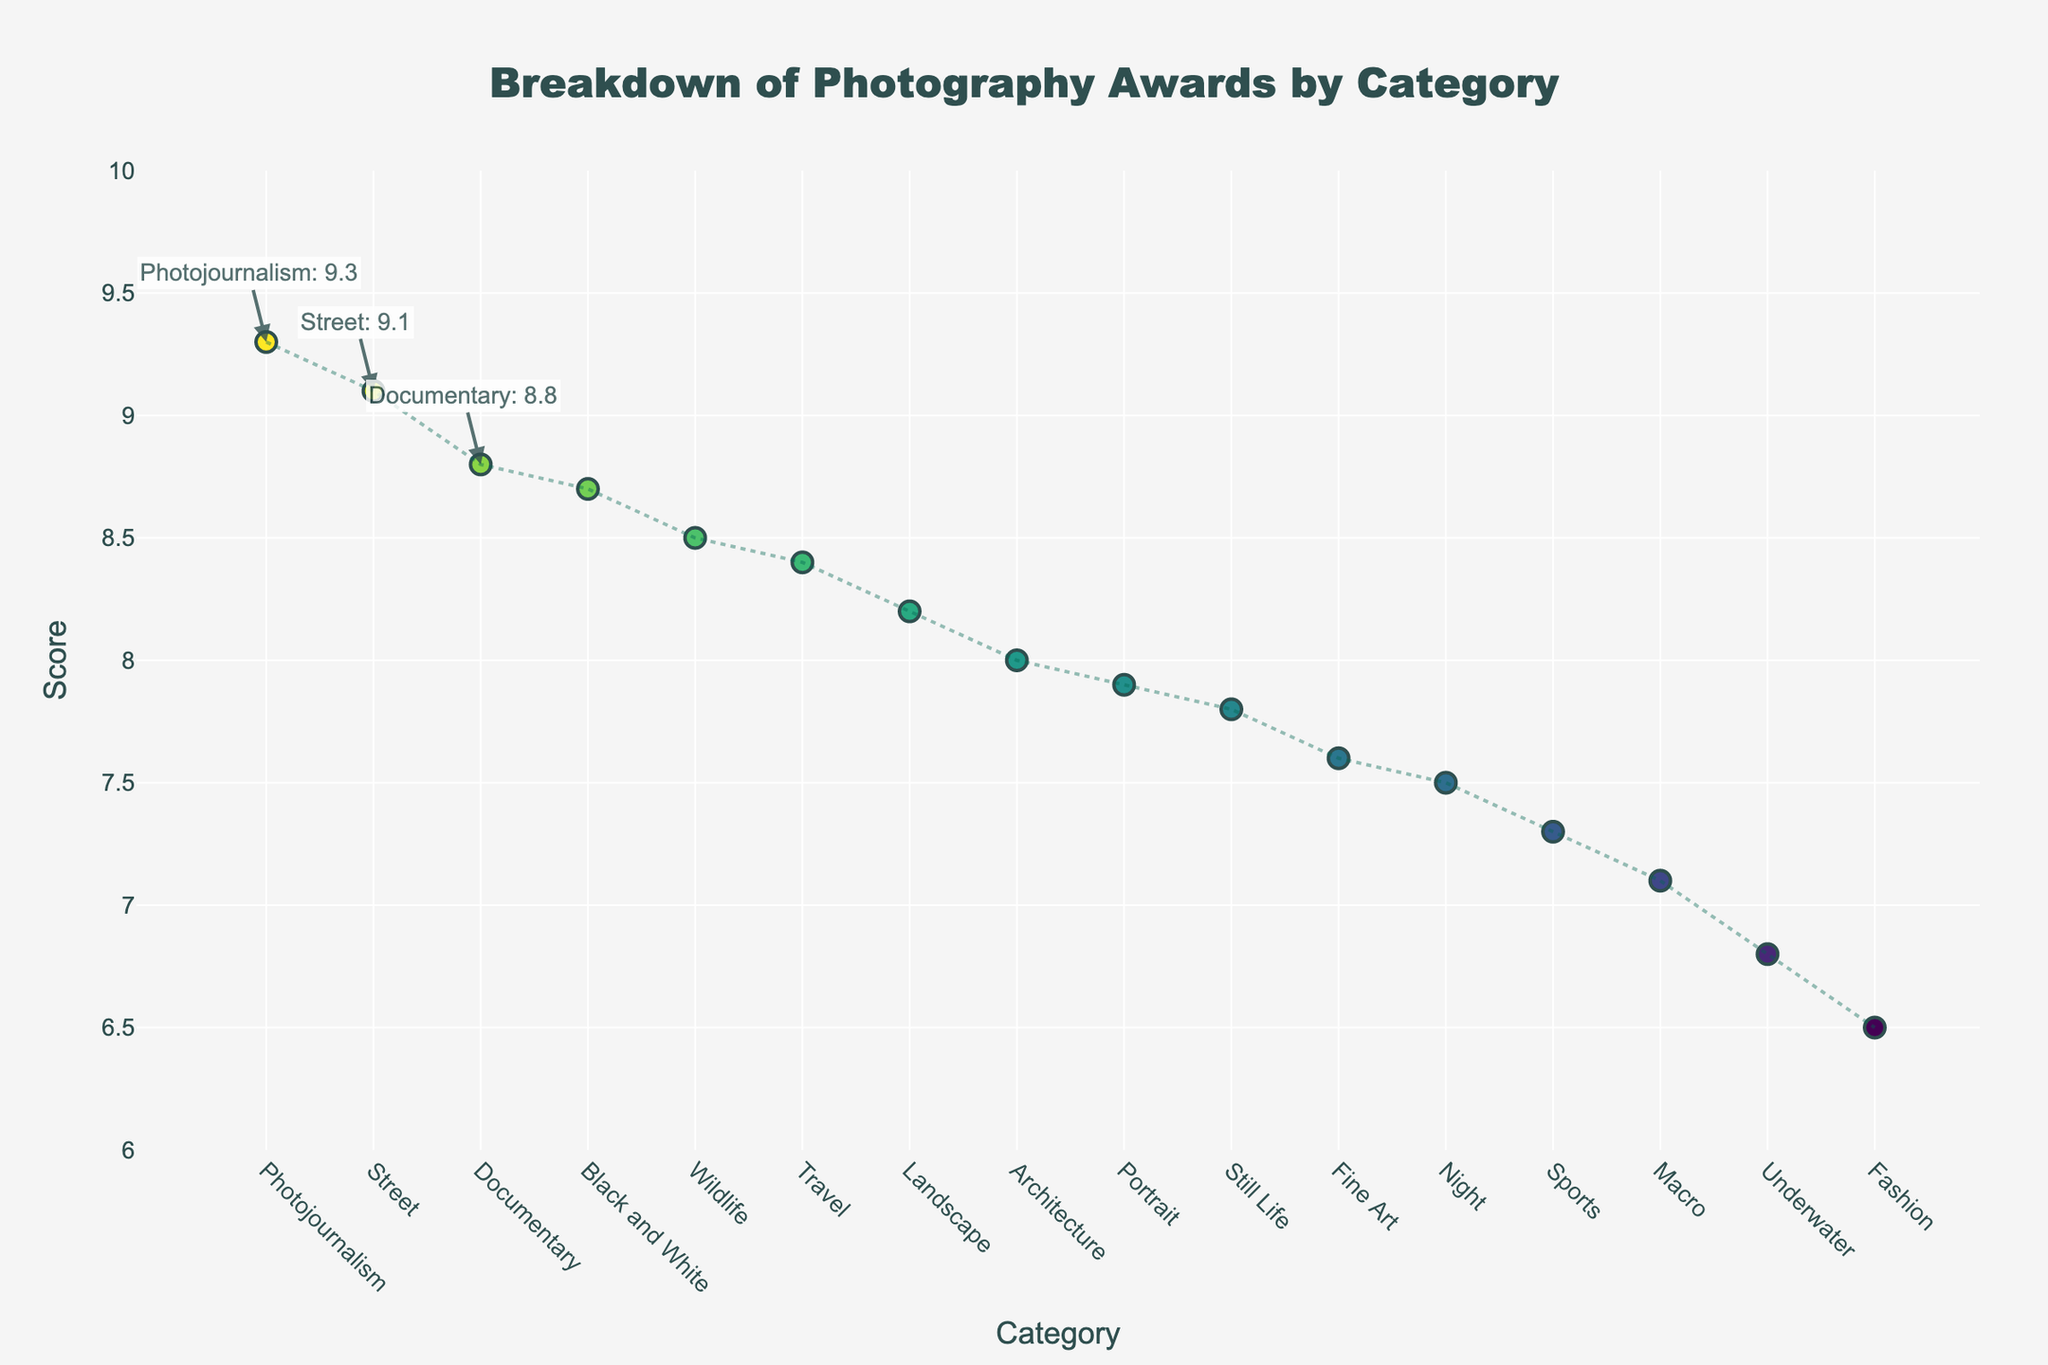What's the title of the plot? The title is usually found at the top of the plot and is the main heading that gives an idea about the content of the plot.
Answer: Breakdown of Photography Awards by Category Which category has the highest score? The highest score is identified by the highest point on the y-axis. In this case, the vertical line most to the top represents the category with the highest score.
Answer: Photojournalism What is the score of the 'Street' category? To find the score of 'Street', locate 'Street' on the x-axis and check its corresponding point on the y-axis.
Answer: 9.1 How many categories have scores greater than 8? Count all points above the '8' mark on the y-axis. Each point represents a category.
Answer: 9 Which category has the lowest score and what is it? The lowest score is identified by the lowest point on the y-axis. The corresponding category on the x-axis will give us the category name.
Answer: Fashion, 6.5 What is the average score of all categories? Add all the scores and divide by the number of categories. The sum of the scores is 122.4. There are 16 categories. So, the average is 122.4/16.
Answer: 7.65 Which categories make up the top 3 in terms of awards? The top 3 categories are those with the highest scores. These are marked with annotations on the plot.
Answer: Photojournalism, Street, Documentary How many categories have scores between 7 and 8? Count all the points that fall between 7 and 8 on the y-axis. Each point represents a category within this range.
Answer: 6 Which two categories have a score difference of exactly 0.1? Look for pairs of categories where the difference between their scores is exactly 0.1. Specifically, locate pairs close to each other on the y-axis and subtract their values.
Answer: Landscape and Architecture Is there any category with a score exactly at the midpoint between the highest and lowest scores? Calculate the midpoint by adding the highest score (9.3) and the lowest score (6.5), then divide by 2. Midpoint is (9.3+6.5)/2 = 7.9. Check if any category has a score of 7.9.
Answer: Yes, Portrait 